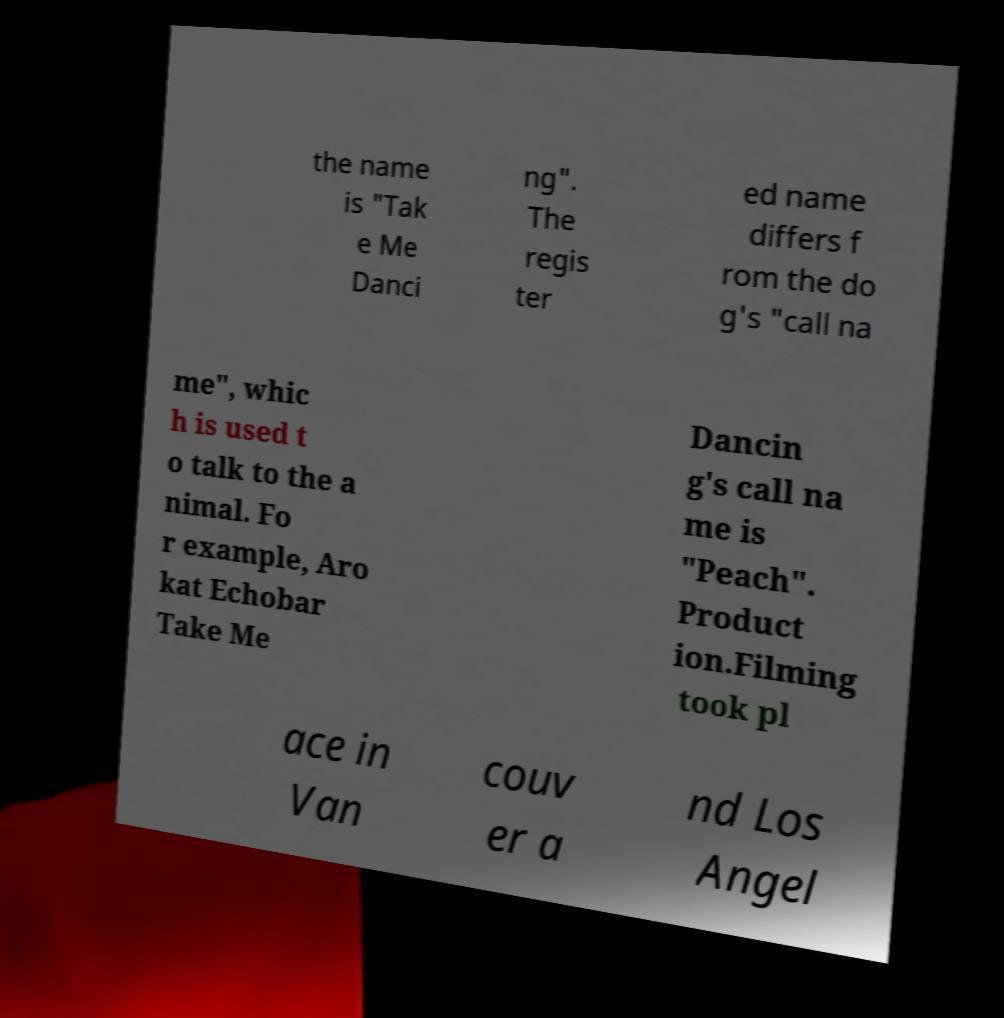Could you assist in decoding the text presented in this image and type it out clearly? the name is "Tak e Me Danci ng". The regis ter ed name differs f rom the do g's "call na me", whic h is used t o talk to the a nimal. Fo r example, Aro kat Echobar Take Me Dancin g's call na me is "Peach". Product ion.Filming took pl ace in Van couv er a nd Los Angel 